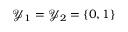<formula> <loc_0><loc_0><loc_500><loc_500>\mathcal { Y } _ { 1 } = \mathcal { Y } _ { 2 } = \{ 0 , 1 \}</formula> 